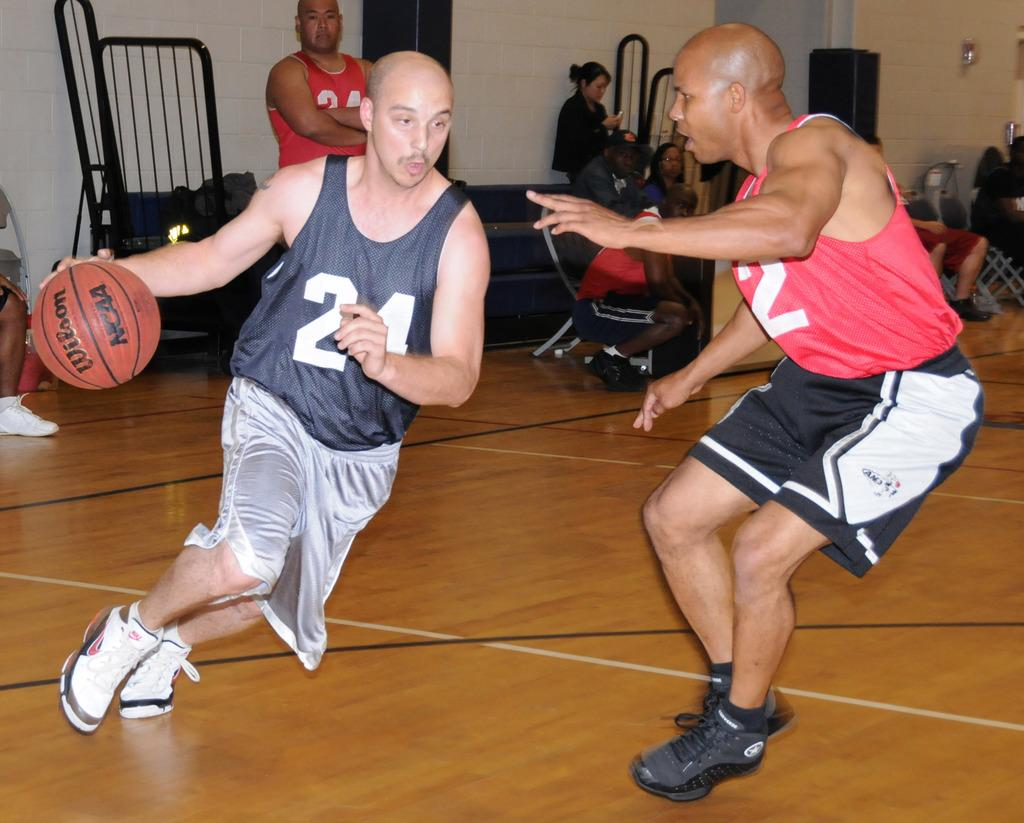Provide a one-sentence caption for the provided image. Two people playing basketball, one with 24 on his shirt. 